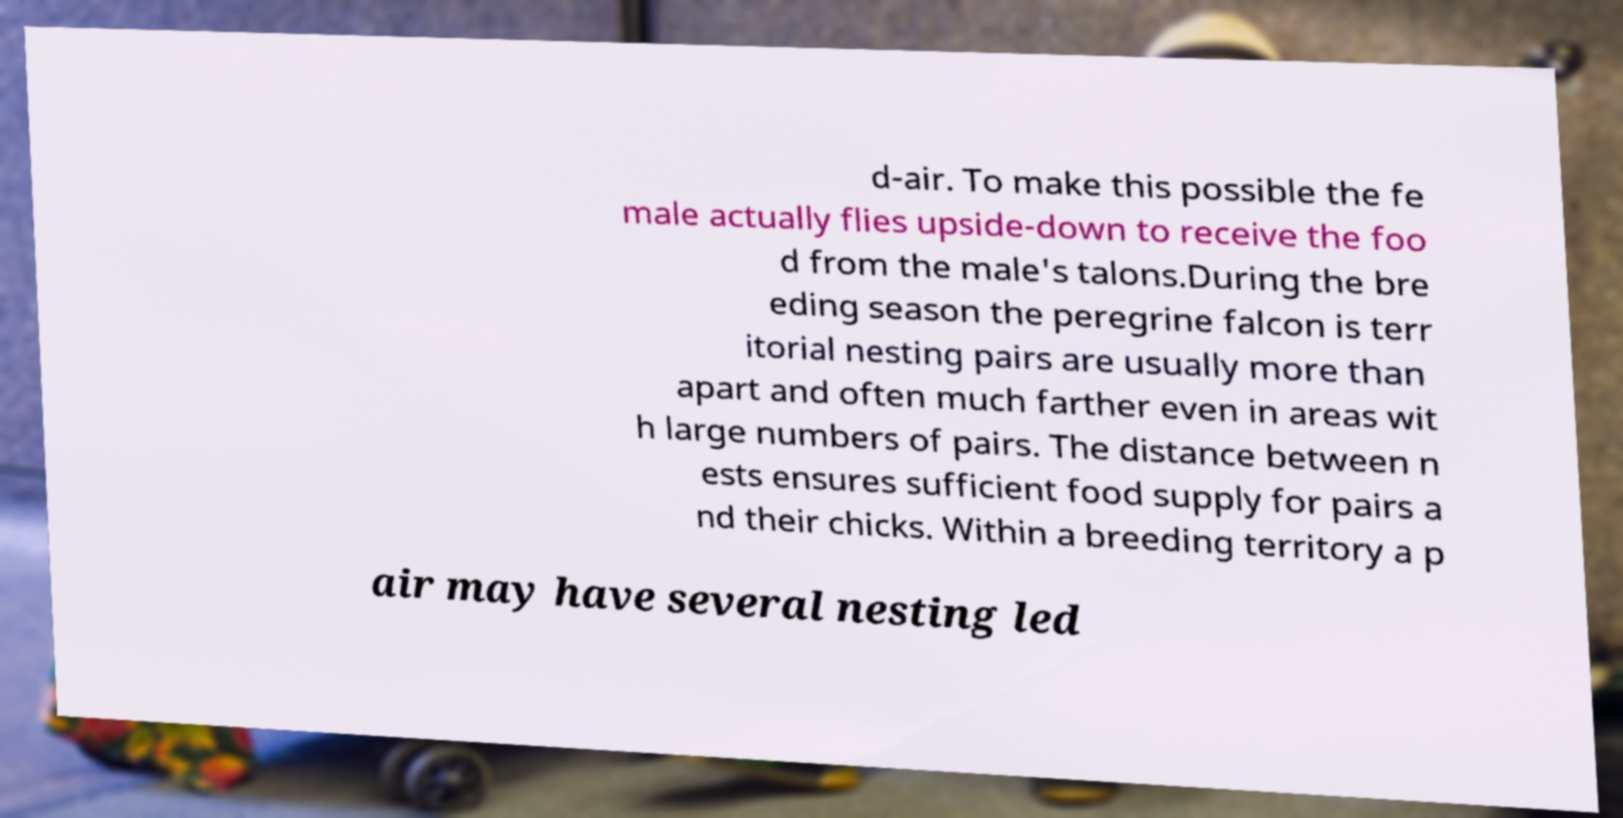For documentation purposes, I need the text within this image transcribed. Could you provide that? d-air. To make this possible the fe male actually flies upside-down to receive the foo d from the male's talons.During the bre eding season the peregrine falcon is terr itorial nesting pairs are usually more than apart and often much farther even in areas wit h large numbers of pairs. The distance between n ests ensures sufficient food supply for pairs a nd their chicks. Within a breeding territory a p air may have several nesting led 